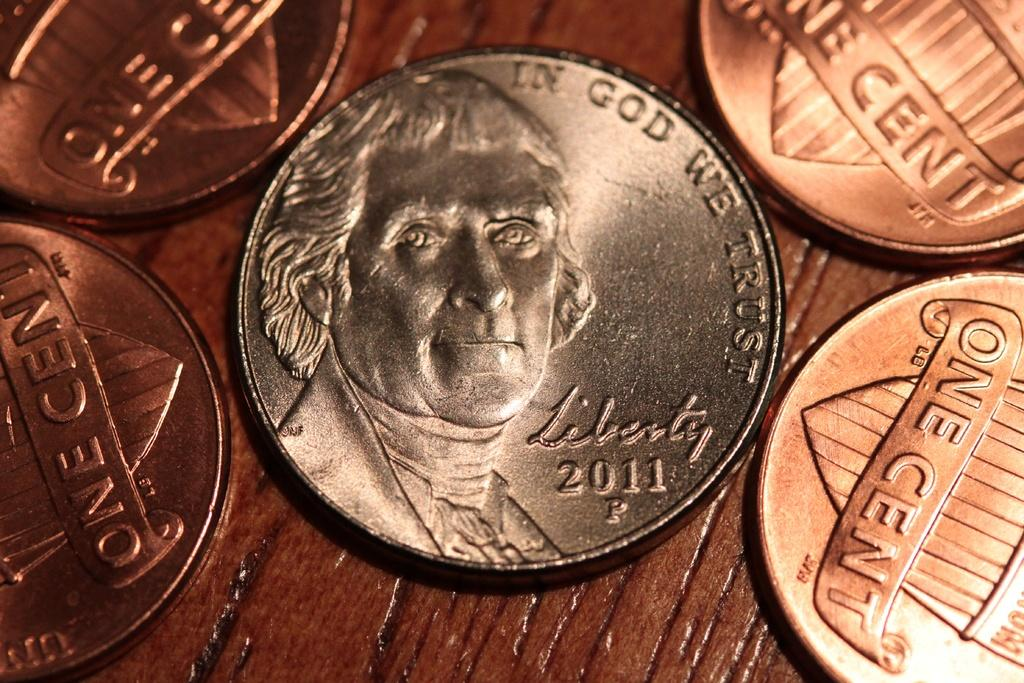<image>
Write a terse but informative summary of the picture. A 2011 nickel is surrounded by four pennies. 